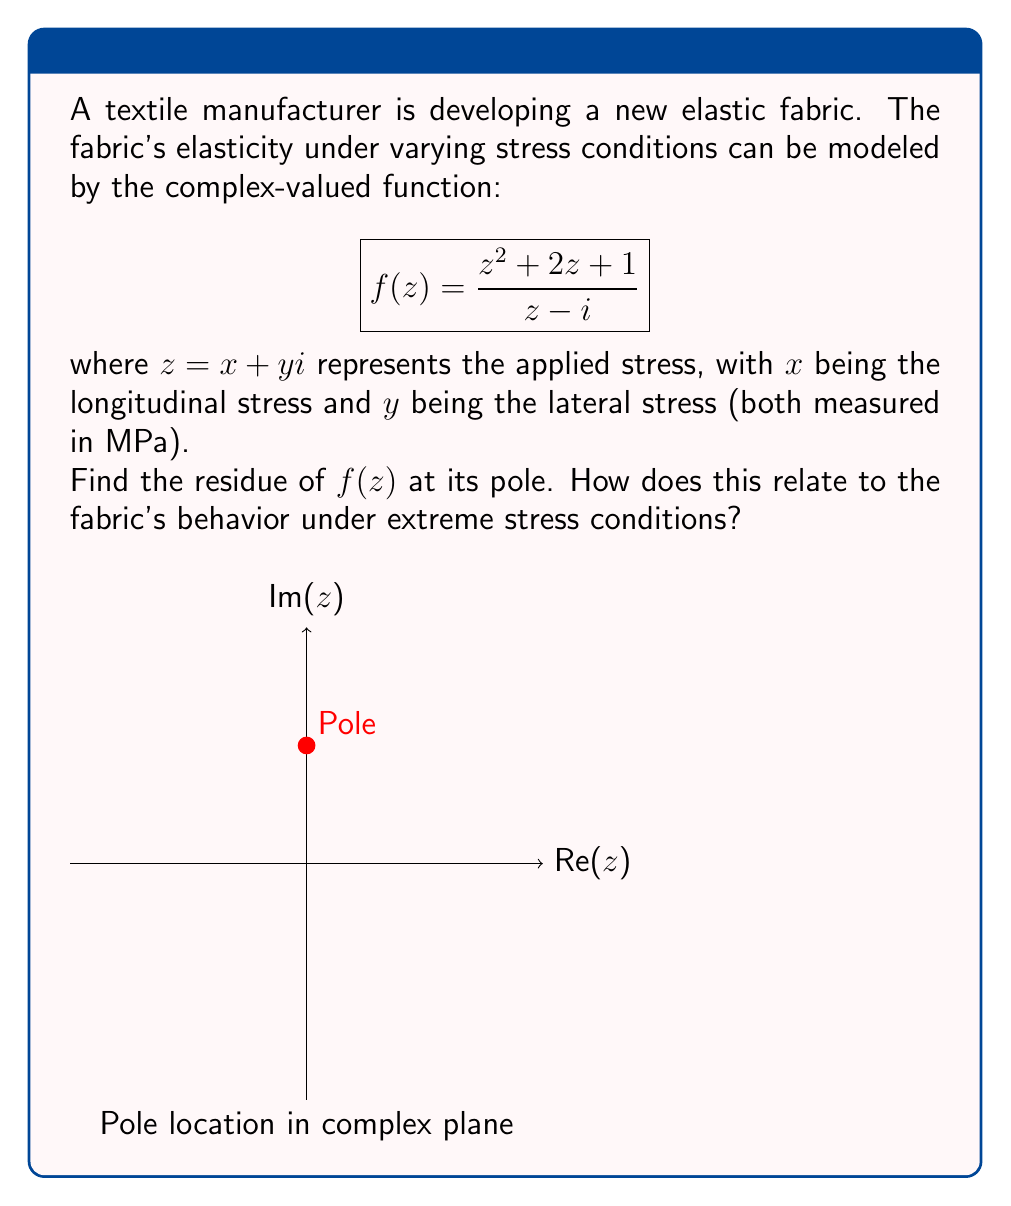Help me with this question. To solve this problem, we'll follow these steps:

1) First, we need to identify the pole of the function. The denominator of $f(z)$ is $z - i$, so the pole is at $z = i$.

2) To find the residue at $z = i$, we can use the formula for a simple pole:
   $$\text{Res}(f, i) = \lim_{z \to i} (z - i)f(z)$$

3) Let's substitute the function and simplify:
   $$\begin{align*}
   \text{Res}(f, i) &= \lim_{z \to i} (z - i)\frac{z^2 + 2z + 1}{z - i} \\
   &= \lim_{z \to i} (z^2 + 2z + 1)
   \end{align*}$$

4) Now we can directly evaluate the limit:
   $$\begin{align*}
   \text{Res}(f, i) &= i^2 + 2i + 1 \\
   &= -1 + 2i + 1 \\
   &= 2i
   \end{align*}$$

5) The residue $2i$ indicates that the function has a significant imaginary component at its pole. In the context of fabric elasticity:

   - The real part (0) suggests no net longitudinal deformation at the critical stress point.
   - The imaginary part (2) indicates a substantial lateral response at this critical point.

This implies that under extreme stress conditions (near the pole), the fabric exhibits a strong lateral expansion or contraction without significant longitudinal change, which could be crucial for the fabric's performance in high-stress applications.
Answer: $2i$ 